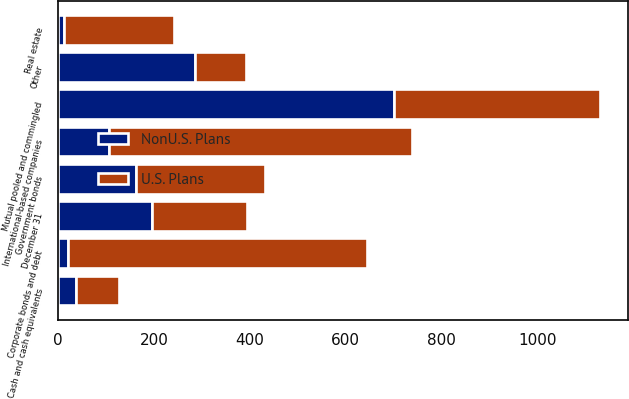<chart> <loc_0><loc_0><loc_500><loc_500><stacked_bar_chart><ecel><fcel>December 31<fcel>Cash and cash equivalents<fcel>International-based companies<fcel>Government bonds<fcel>Corporate bonds and debt<fcel>Mutual pooled and commingled<fcel>Real estate<fcel>Other<nl><fcel>U.S. Plans<fcel>196.5<fcel>88<fcel>631<fcel>268<fcel>625<fcel>431<fcel>230<fcel>106<nl><fcel>NonU.S. Plans<fcel>196.5<fcel>38<fcel>107<fcel>163<fcel>20<fcel>700<fcel>12<fcel>286<nl></chart> 